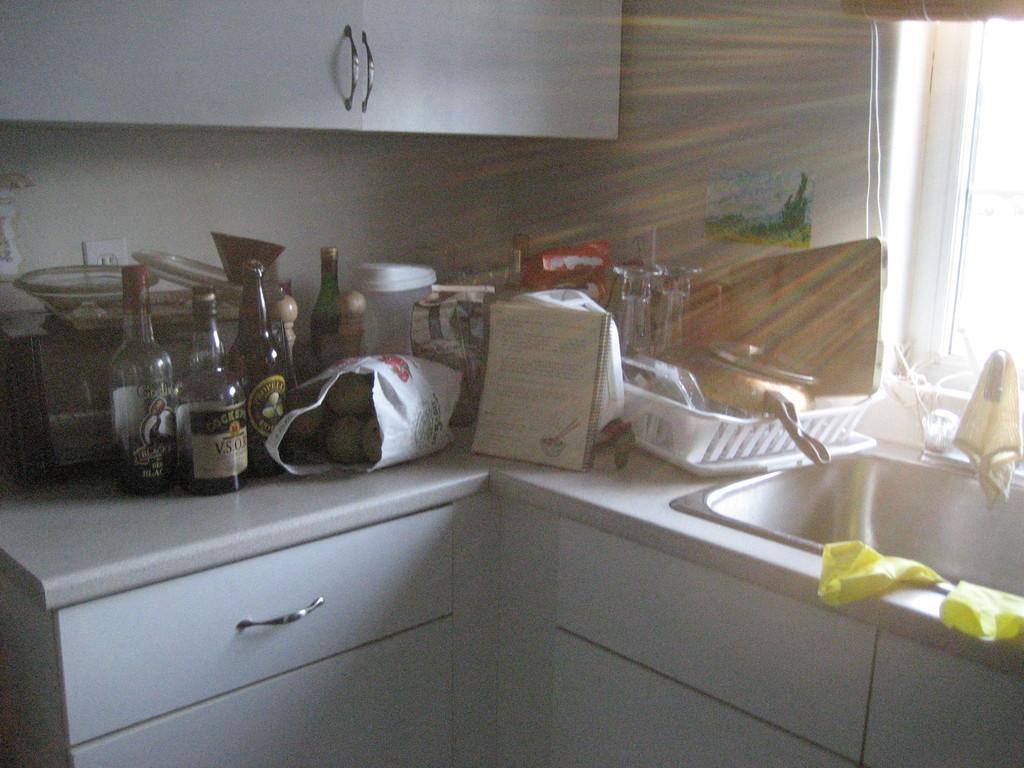Describe this image in one or two sentences. This is clicked inside a kitchen, on the right side there is wash basin with a basket,pan,glasses,bottles,cover,book and utensils on the table with a drawer below it and above there is a cupboard, on the right side there is window on the wall. 